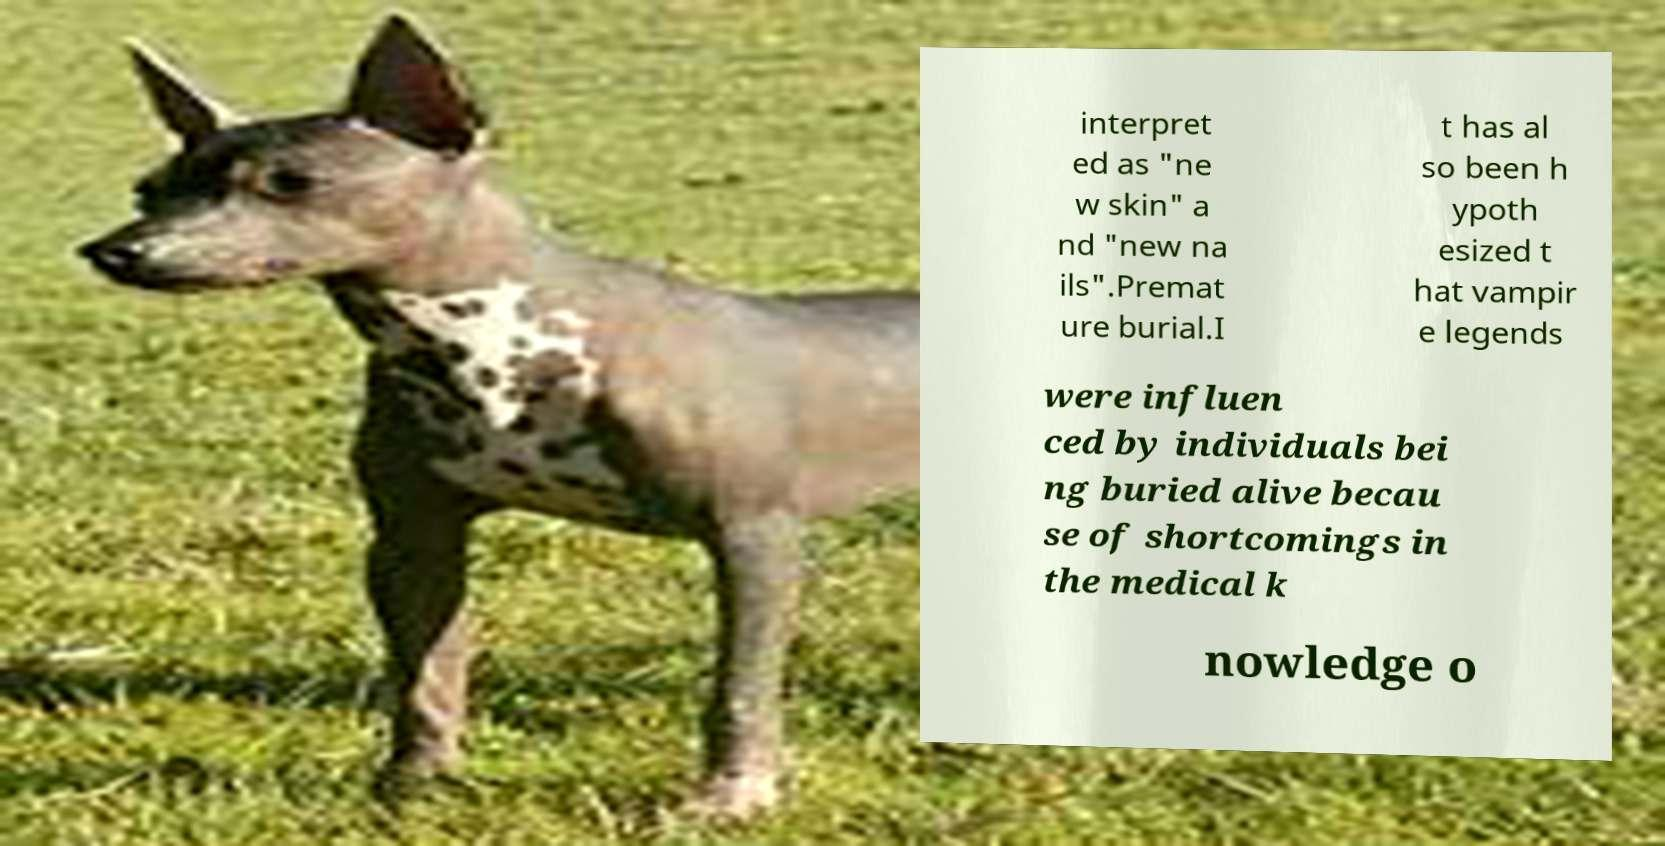Could you extract and type out the text from this image? interpret ed as "ne w skin" a nd "new na ils".Premat ure burial.I t has al so been h ypoth esized t hat vampir e legends were influen ced by individuals bei ng buried alive becau se of shortcomings in the medical k nowledge o 